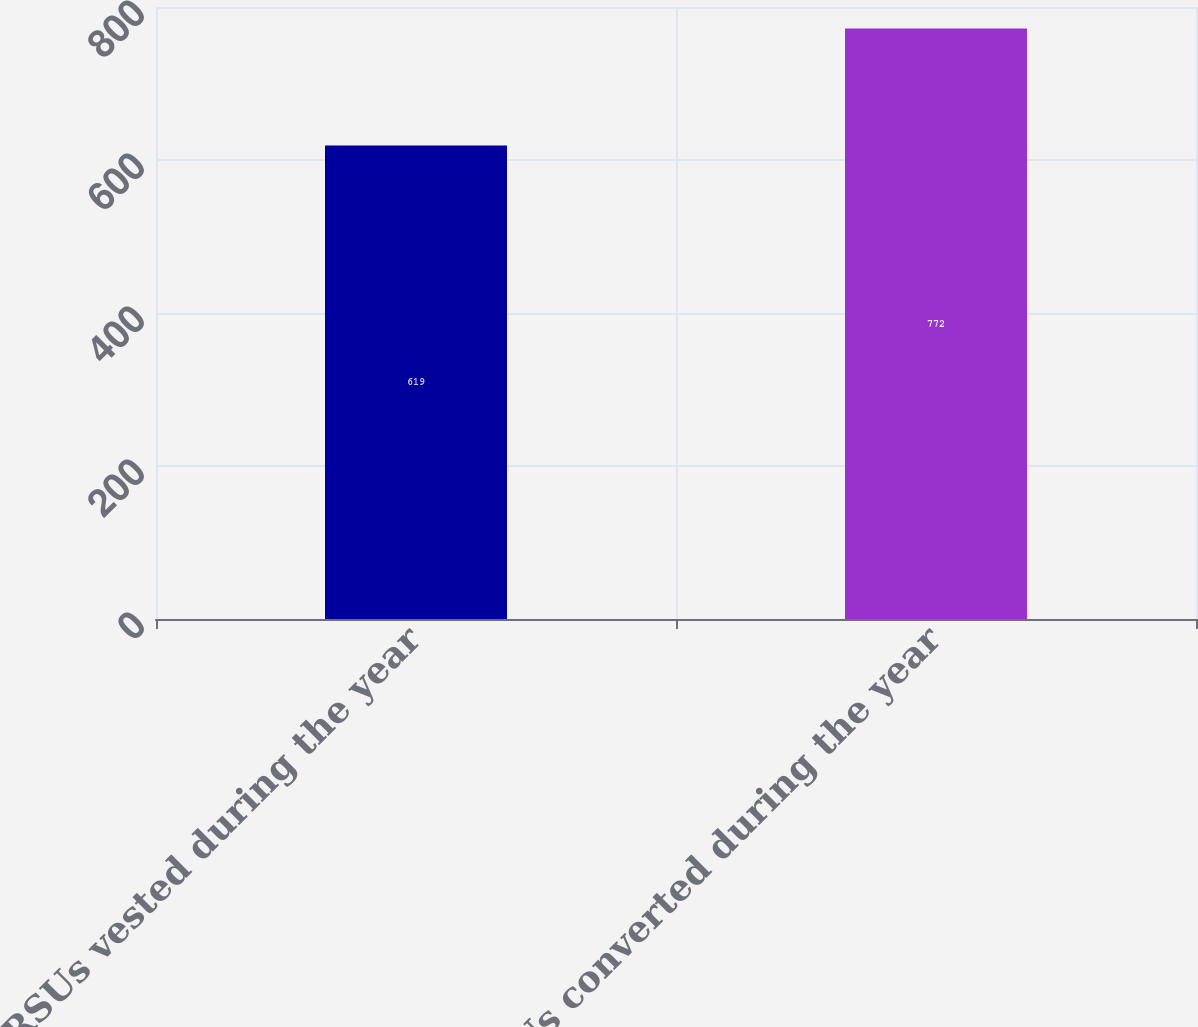<chart> <loc_0><loc_0><loc_500><loc_500><bar_chart><fcel>RSUs vested during the year<fcel>RSUs converted during the year<nl><fcel>619<fcel>772<nl></chart> 